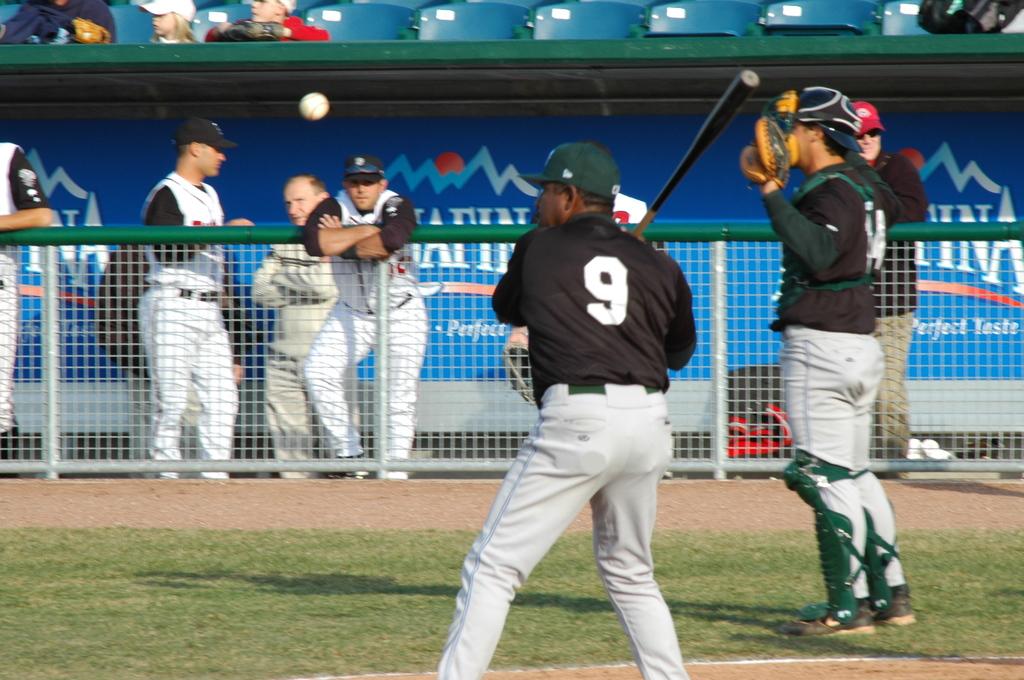What number is the baseball player?
Your response must be concise. 9. What number is the baseball holding the mitt?
Provide a short and direct response. 9. 